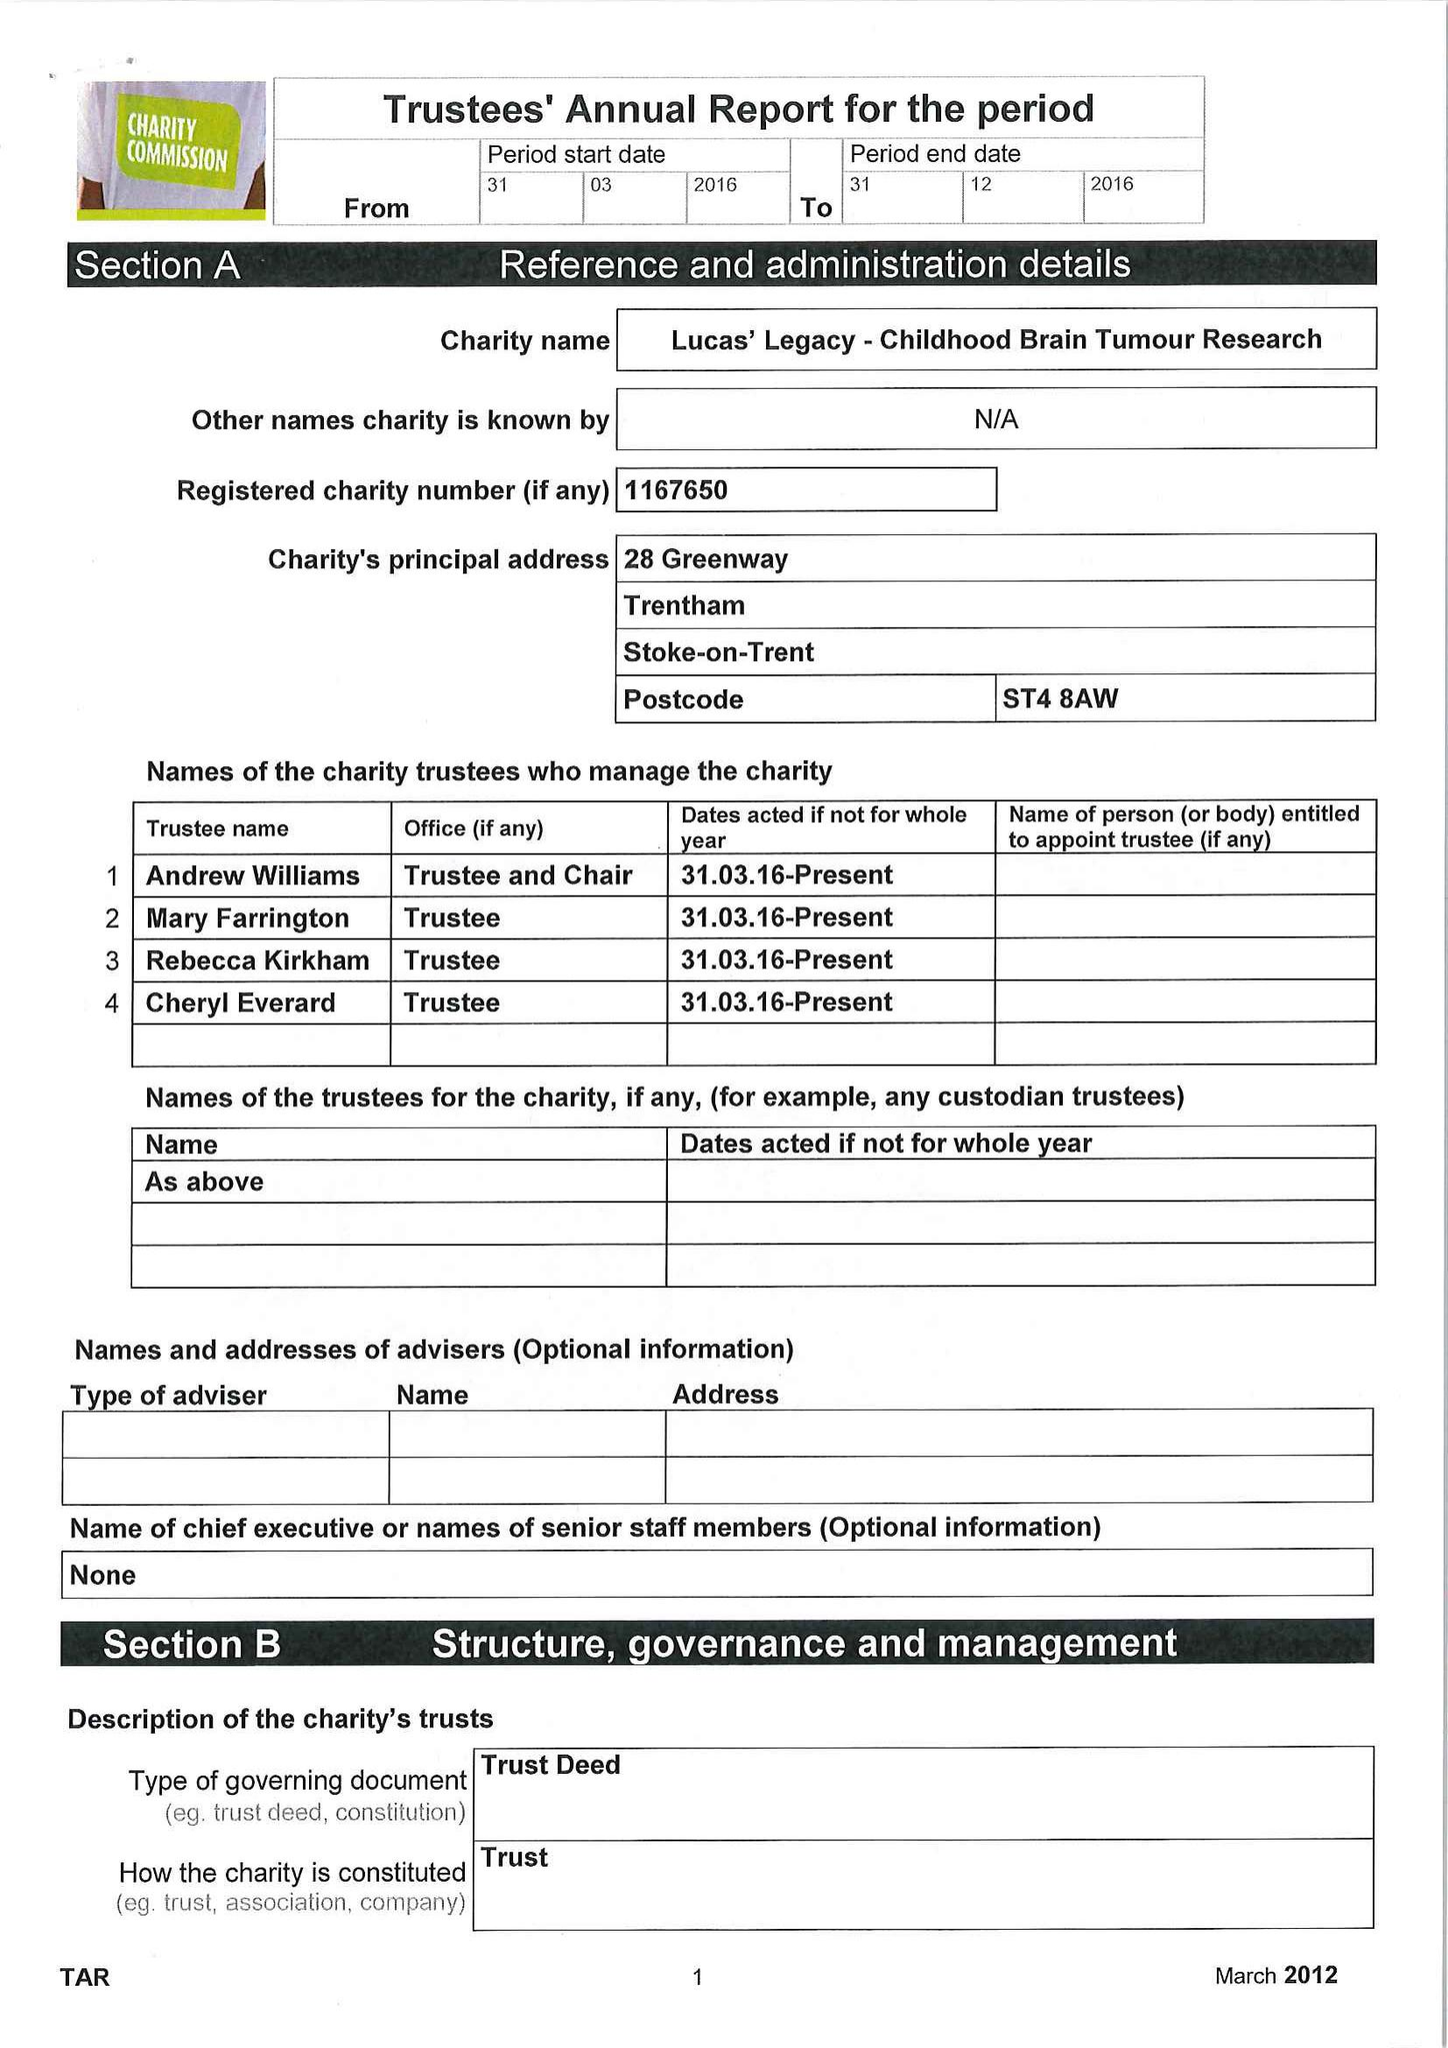What is the value for the address__postcode?
Answer the question using a single word or phrase. ST4 8AW 